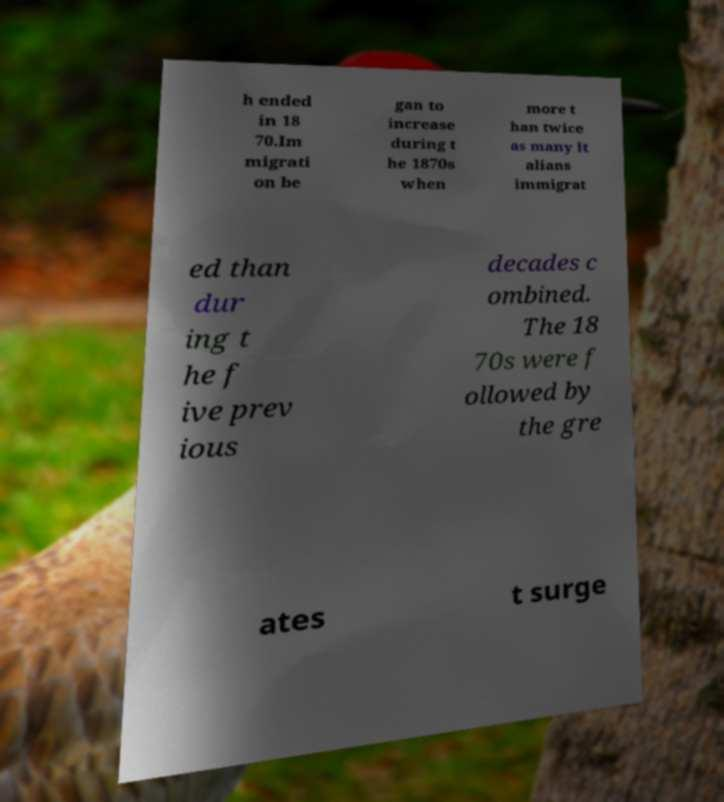Can you accurately transcribe the text from the provided image for me? h ended in 18 70.Im migrati on be gan to increase during t he 1870s when more t han twice as many It alians immigrat ed than dur ing t he f ive prev ious decades c ombined. The 18 70s were f ollowed by the gre ates t surge 